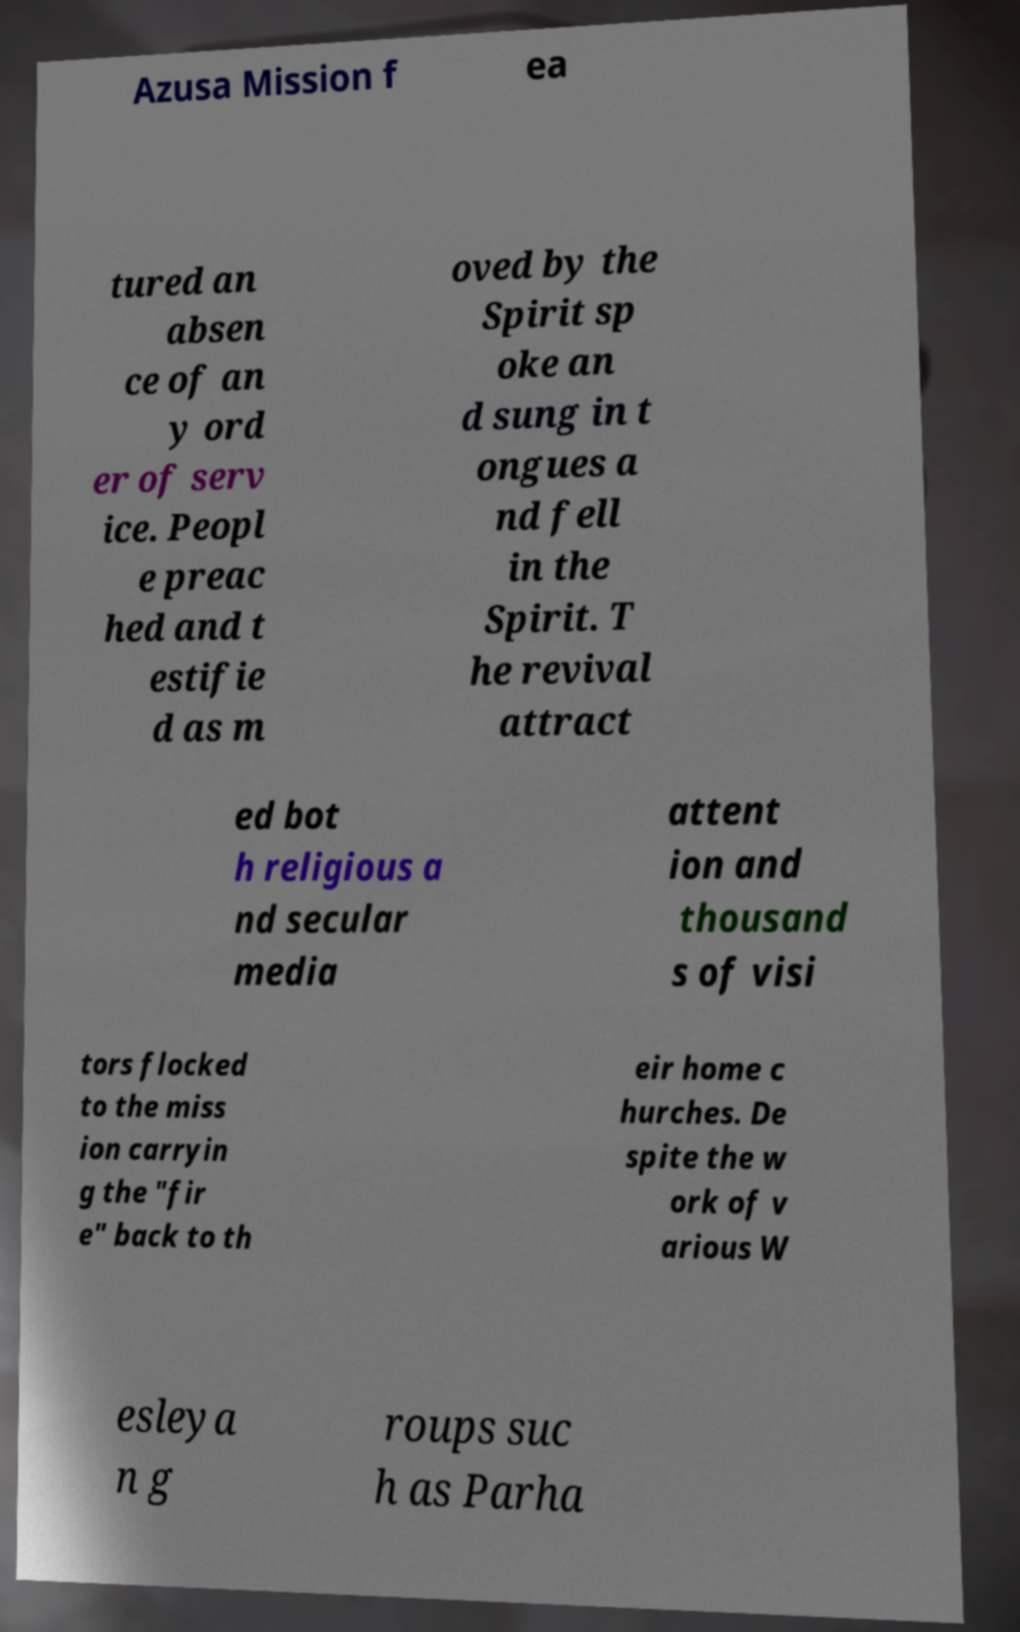Please read and relay the text visible in this image. What does it say? Azusa Mission f ea tured an absen ce of an y ord er of serv ice. Peopl e preac hed and t estifie d as m oved by the Spirit sp oke an d sung in t ongues a nd fell in the Spirit. T he revival attract ed bot h religious a nd secular media attent ion and thousand s of visi tors flocked to the miss ion carryin g the "fir e" back to th eir home c hurches. De spite the w ork of v arious W esleya n g roups suc h as Parha 